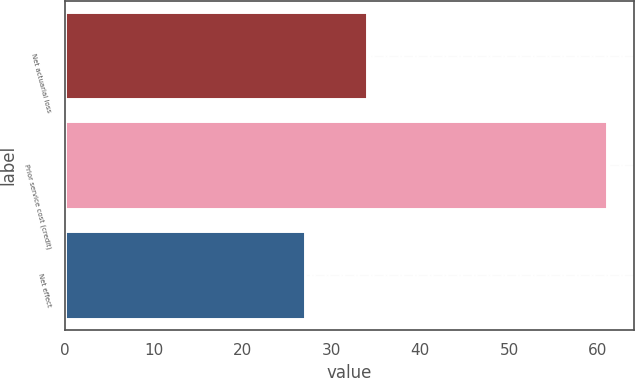Convert chart. <chart><loc_0><loc_0><loc_500><loc_500><bar_chart><fcel>Net actuarial loss<fcel>Prior service cost (credit)<fcel>Net effect<nl><fcel>34<fcel>61<fcel>27<nl></chart> 